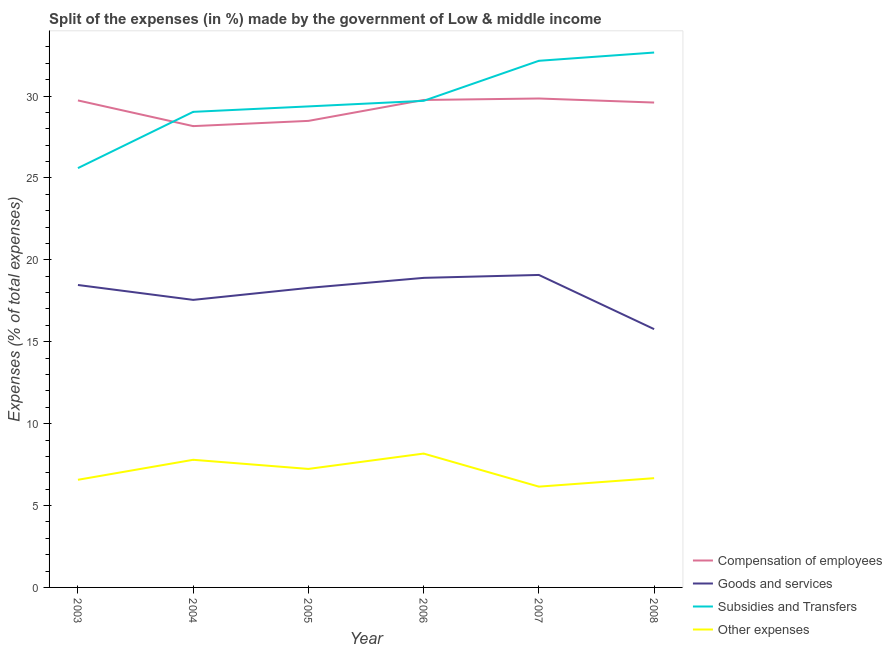How many different coloured lines are there?
Your response must be concise. 4. Does the line corresponding to percentage of amount spent on other expenses intersect with the line corresponding to percentage of amount spent on subsidies?
Your answer should be very brief. No. Is the number of lines equal to the number of legend labels?
Your answer should be very brief. Yes. What is the percentage of amount spent on subsidies in 2007?
Make the answer very short. 32.15. Across all years, what is the maximum percentage of amount spent on compensation of employees?
Your response must be concise. 29.85. Across all years, what is the minimum percentage of amount spent on other expenses?
Ensure brevity in your answer.  6.15. In which year was the percentage of amount spent on goods and services minimum?
Provide a short and direct response. 2008. What is the total percentage of amount spent on other expenses in the graph?
Make the answer very short. 42.6. What is the difference between the percentage of amount spent on subsidies in 2003 and that in 2008?
Keep it short and to the point. -7.06. What is the difference between the percentage of amount spent on subsidies in 2004 and the percentage of amount spent on compensation of employees in 2005?
Your answer should be compact. 0.55. What is the average percentage of amount spent on other expenses per year?
Give a very brief answer. 7.1. In the year 2008, what is the difference between the percentage of amount spent on subsidies and percentage of amount spent on other expenses?
Keep it short and to the point. 25.99. What is the ratio of the percentage of amount spent on goods and services in 2007 to that in 2008?
Give a very brief answer. 1.21. What is the difference between the highest and the second highest percentage of amount spent on compensation of employees?
Provide a short and direct response. 0.09. What is the difference between the highest and the lowest percentage of amount spent on goods and services?
Your answer should be very brief. 3.31. Is the sum of the percentage of amount spent on compensation of employees in 2006 and 2008 greater than the maximum percentage of amount spent on goods and services across all years?
Your answer should be compact. Yes. Is it the case that in every year, the sum of the percentage of amount spent on compensation of employees and percentage of amount spent on goods and services is greater than the percentage of amount spent on subsidies?
Provide a succinct answer. Yes. Is the percentage of amount spent on compensation of employees strictly greater than the percentage of amount spent on subsidies over the years?
Your answer should be very brief. No. Is the percentage of amount spent on other expenses strictly less than the percentage of amount spent on subsidies over the years?
Provide a short and direct response. Yes. How many lines are there?
Your response must be concise. 4. How many years are there in the graph?
Your response must be concise. 6. What is the difference between two consecutive major ticks on the Y-axis?
Make the answer very short. 5. Are the values on the major ticks of Y-axis written in scientific E-notation?
Provide a short and direct response. No. Does the graph contain any zero values?
Provide a succinct answer. No. Does the graph contain grids?
Provide a short and direct response. No. Where does the legend appear in the graph?
Ensure brevity in your answer.  Bottom right. How many legend labels are there?
Make the answer very short. 4. What is the title of the graph?
Ensure brevity in your answer.  Split of the expenses (in %) made by the government of Low & middle income. Does "Management rating" appear as one of the legend labels in the graph?
Ensure brevity in your answer.  No. What is the label or title of the Y-axis?
Make the answer very short. Expenses (% of total expenses). What is the Expenses (% of total expenses) in Compensation of employees in 2003?
Keep it short and to the point. 29.73. What is the Expenses (% of total expenses) in Goods and services in 2003?
Ensure brevity in your answer.  18.46. What is the Expenses (% of total expenses) in Subsidies and Transfers in 2003?
Make the answer very short. 25.6. What is the Expenses (% of total expenses) in Other expenses in 2003?
Keep it short and to the point. 6.57. What is the Expenses (% of total expenses) in Compensation of employees in 2004?
Give a very brief answer. 28.17. What is the Expenses (% of total expenses) in Goods and services in 2004?
Give a very brief answer. 17.56. What is the Expenses (% of total expenses) of Subsidies and Transfers in 2004?
Keep it short and to the point. 29.04. What is the Expenses (% of total expenses) of Other expenses in 2004?
Offer a terse response. 7.79. What is the Expenses (% of total expenses) in Compensation of employees in 2005?
Provide a short and direct response. 28.48. What is the Expenses (% of total expenses) in Goods and services in 2005?
Your answer should be very brief. 18.29. What is the Expenses (% of total expenses) in Subsidies and Transfers in 2005?
Provide a succinct answer. 29.37. What is the Expenses (% of total expenses) of Other expenses in 2005?
Keep it short and to the point. 7.24. What is the Expenses (% of total expenses) of Compensation of employees in 2006?
Your answer should be compact. 29.76. What is the Expenses (% of total expenses) of Goods and services in 2006?
Your answer should be compact. 18.9. What is the Expenses (% of total expenses) in Subsidies and Transfers in 2006?
Make the answer very short. 29.71. What is the Expenses (% of total expenses) of Other expenses in 2006?
Make the answer very short. 8.17. What is the Expenses (% of total expenses) of Compensation of employees in 2007?
Your response must be concise. 29.85. What is the Expenses (% of total expenses) of Goods and services in 2007?
Offer a very short reply. 19.08. What is the Expenses (% of total expenses) in Subsidies and Transfers in 2007?
Offer a terse response. 32.15. What is the Expenses (% of total expenses) in Other expenses in 2007?
Offer a terse response. 6.15. What is the Expenses (% of total expenses) of Compensation of employees in 2008?
Your response must be concise. 29.6. What is the Expenses (% of total expenses) in Goods and services in 2008?
Provide a succinct answer. 15.77. What is the Expenses (% of total expenses) of Subsidies and Transfers in 2008?
Your response must be concise. 32.66. What is the Expenses (% of total expenses) in Other expenses in 2008?
Provide a succinct answer. 6.67. Across all years, what is the maximum Expenses (% of total expenses) in Compensation of employees?
Keep it short and to the point. 29.85. Across all years, what is the maximum Expenses (% of total expenses) of Goods and services?
Your answer should be compact. 19.08. Across all years, what is the maximum Expenses (% of total expenses) in Subsidies and Transfers?
Your answer should be compact. 32.66. Across all years, what is the maximum Expenses (% of total expenses) of Other expenses?
Your answer should be compact. 8.17. Across all years, what is the minimum Expenses (% of total expenses) of Compensation of employees?
Offer a terse response. 28.17. Across all years, what is the minimum Expenses (% of total expenses) in Goods and services?
Your response must be concise. 15.77. Across all years, what is the minimum Expenses (% of total expenses) in Subsidies and Transfers?
Keep it short and to the point. 25.6. Across all years, what is the minimum Expenses (% of total expenses) of Other expenses?
Give a very brief answer. 6.15. What is the total Expenses (% of total expenses) in Compensation of employees in the graph?
Your answer should be very brief. 175.6. What is the total Expenses (% of total expenses) in Goods and services in the graph?
Keep it short and to the point. 108.06. What is the total Expenses (% of total expenses) of Subsidies and Transfers in the graph?
Make the answer very short. 178.53. What is the total Expenses (% of total expenses) in Other expenses in the graph?
Offer a very short reply. 42.6. What is the difference between the Expenses (% of total expenses) in Compensation of employees in 2003 and that in 2004?
Offer a terse response. 1.57. What is the difference between the Expenses (% of total expenses) of Goods and services in 2003 and that in 2004?
Offer a very short reply. 0.91. What is the difference between the Expenses (% of total expenses) in Subsidies and Transfers in 2003 and that in 2004?
Offer a terse response. -3.43. What is the difference between the Expenses (% of total expenses) in Other expenses in 2003 and that in 2004?
Your answer should be very brief. -1.22. What is the difference between the Expenses (% of total expenses) in Compensation of employees in 2003 and that in 2005?
Your response must be concise. 1.25. What is the difference between the Expenses (% of total expenses) of Goods and services in 2003 and that in 2005?
Ensure brevity in your answer.  0.18. What is the difference between the Expenses (% of total expenses) in Subsidies and Transfers in 2003 and that in 2005?
Ensure brevity in your answer.  -3.77. What is the difference between the Expenses (% of total expenses) of Other expenses in 2003 and that in 2005?
Give a very brief answer. -0.66. What is the difference between the Expenses (% of total expenses) of Compensation of employees in 2003 and that in 2006?
Offer a terse response. -0.03. What is the difference between the Expenses (% of total expenses) in Goods and services in 2003 and that in 2006?
Your response must be concise. -0.44. What is the difference between the Expenses (% of total expenses) of Subsidies and Transfers in 2003 and that in 2006?
Make the answer very short. -4.11. What is the difference between the Expenses (% of total expenses) of Other expenses in 2003 and that in 2006?
Give a very brief answer. -1.6. What is the difference between the Expenses (% of total expenses) in Compensation of employees in 2003 and that in 2007?
Ensure brevity in your answer.  -0.12. What is the difference between the Expenses (% of total expenses) in Goods and services in 2003 and that in 2007?
Ensure brevity in your answer.  -0.61. What is the difference between the Expenses (% of total expenses) of Subsidies and Transfers in 2003 and that in 2007?
Provide a succinct answer. -6.55. What is the difference between the Expenses (% of total expenses) in Other expenses in 2003 and that in 2007?
Offer a very short reply. 0.42. What is the difference between the Expenses (% of total expenses) in Compensation of employees in 2003 and that in 2008?
Make the answer very short. 0.13. What is the difference between the Expenses (% of total expenses) in Goods and services in 2003 and that in 2008?
Offer a terse response. 2.69. What is the difference between the Expenses (% of total expenses) of Subsidies and Transfers in 2003 and that in 2008?
Provide a succinct answer. -7.06. What is the difference between the Expenses (% of total expenses) in Other expenses in 2003 and that in 2008?
Make the answer very short. -0.1. What is the difference between the Expenses (% of total expenses) in Compensation of employees in 2004 and that in 2005?
Give a very brief answer. -0.32. What is the difference between the Expenses (% of total expenses) in Goods and services in 2004 and that in 2005?
Offer a very short reply. -0.73. What is the difference between the Expenses (% of total expenses) of Subsidies and Transfers in 2004 and that in 2005?
Keep it short and to the point. -0.33. What is the difference between the Expenses (% of total expenses) in Other expenses in 2004 and that in 2005?
Keep it short and to the point. 0.56. What is the difference between the Expenses (% of total expenses) of Compensation of employees in 2004 and that in 2006?
Offer a terse response. -1.6. What is the difference between the Expenses (% of total expenses) in Goods and services in 2004 and that in 2006?
Your response must be concise. -1.34. What is the difference between the Expenses (% of total expenses) in Subsidies and Transfers in 2004 and that in 2006?
Keep it short and to the point. -0.67. What is the difference between the Expenses (% of total expenses) in Other expenses in 2004 and that in 2006?
Give a very brief answer. -0.38. What is the difference between the Expenses (% of total expenses) of Compensation of employees in 2004 and that in 2007?
Ensure brevity in your answer.  -1.69. What is the difference between the Expenses (% of total expenses) in Goods and services in 2004 and that in 2007?
Provide a short and direct response. -1.52. What is the difference between the Expenses (% of total expenses) in Subsidies and Transfers in 2004 and that in 2007?
Your response must be concise. -3.12. What is the difference between the Expenses (% of total expenses) in Other expenses in 2004 and that in 2007?
Keep it short and to the point. 1.64. What is the difference between the Expenses (% of total expenses) in Compensation of employees in 2004 and that in 2008?
Your response must be concise. -1.44. What is the difference between the Expenses (% of total expenses) in Goods and services in 2004 and that in 2008?
Provide a short and direct response. 1.79. What is the difference between the Expenses (% of total expenses) of Subsidies and Transfers in 2004 and that in 2008?
Offer a very short reply. -3.62. What is the difference between the Expenses (% of total expenses) in Other expenses in 2004 and that in 2008?
Offer a terse response. 1.12. What is the difference between the Expenses (% of total expenses) in Compensation of employees in 2005 and that in 2006?
Make the answer very short. -1.28. What is the difference between the Expenses (% of total expenses) in Goods and services in 2005 and that in 2006?
Keep it short and to the point. -0.61. What is the difference between the Expenses (% of total expenses) of Subsidies and Transfers in 2005 and that in 2006?
Your answer should be compact. -0.34. What is the difference between the Expenses (% of total expenses) of Other expenses in 2005 and that in 2006?
Your answer should be very brief. -0.94. What is the difference between the Expenses (% of total expenses) of Compensation of employees in 2005 and that in 2007?
Give a very brief answer. -1.37. What is the difference between the Expenses (% of total expenses) of Goods and services in 2005 and that in 2007?
Make the answer very short. -0.79. What is the difference between the Expenses (% of total expenses) of Subsidies and Transfers in 2005 and that in 2007?
Your answer should be compact. -2.78. What is the difference between the Expenses (% of total expenses) of Other expenses in 2005 and that in 2007?
Give a very brief answer. 1.08. What is the difference between the Expenses (% of total expenses) in Compensation of employees in 2005 and that in 2008?
Your answer should be very brief. -1.12. What is the difference between the Expenses (% of total expenses) of Goods and services in 2005 and that in 2008?
Give a very brief answer. 2.52. What is the difference between the Expenses (% of total expenses) of Subsidies and Transfers in 2005 and that in 2008?
Offer a terse response. -3.29. What is the difference between the Expenses (% of total expenses) in Other expenses in 2005 and that in 2008?
Your answer should be compact. 0.56. What is the difference between the Expenses (% of total expenses) of Compensation of employees in 2006 and that in 2007?
Provide a succinct answer. -0.09. What is the difference between the Expenses (% of total expenses) of Goods and services in 2006 and that in 2007?
Keep it short and to the point. -0.18. What is the difference between the Expenses (% of total expenses) of Subsidies and Transfers in 2006 and that in 2007?
Ensure brevity in your answer.  -2.44. What is the difference between the Expenses (% of total expenses) in Other expenses in 2006 and that in 2007?
Your response must be concise. 2.02. What is the difference between the Expenses (% of total expenses) in Compensation of employees in 2006 and that in 2008?
Keep it short and to the point. 0.16. What is the difference between the Expenses (% of total expenses) in Goods and services in 2006 and that in 2008?
Your answer should be compact. 3.13. What is the difference between the Expenses (% of total expenses) of Subsidies and Transfers in 2006 and that in 2008?
Make the answer very short. -2.95. What is the difference between the Expenses (% of total expenses) of Other expenses in 2006 and that in 2008?
Keep it short and to the point. 1.5. What is the difference between the Expenses (% of total expenses) of Compensation of employees in 2007 and that in 2008?
Provide a short and direct response. 0.25. What is the difference between the Expenses (% of total expenses) of Goods and services in 2007 and that in 2008?
Ensure brevity in your answer.  3.31. What is the difference between the Expenses (% of total expenses) in Subsidies and Transfers in 2007 and that in 2008?
Your response must be concise. -0.5. What is the difference between the Expenses (% of total expenses) in Other expenses in 2007 and that in 2008?
Make the answer very short. -0.52. What is the difference between the Expenses (% of total expenses) of Compensation of employees in 2003 and the Expenses (% of total expenses) of Goods and services in 2004?
Give a very brief answer. 12.18. What is the difference between the Expenses (% of total expenses) of Compensation of employees in 2003 and the Expenses (% of total expenses) of Subsidies and Transfers in 2004?
Give a very brief answer. 0.7. What is the difference between the Expenses (% of total expenses) in Compensation of employees in 2003 and the Expenses (% of total expenses) in Other expenses in 2004?
Offer a very short reply. 21.94. What is the difference between the Expenses (% of total expenses) in Goods and services in 2003 and the Expenses (% of total expenses) in Subsidies and Transfers in 2004?
Provide a succinct answer. -10.57. What is the difference between the Expenses (% of total expenses) in Goods and services in 2003 and the Expenses (% of total expenses) in Other expenses in 2004?
Offer a very short reply. 10.67. What is the difference between the Expenses (% of total expenses) in Subsidies and Transfers in 2003 and the Expenses (% of total expenses) in Other expenses in 2004?
Make the answer very short. 17.81. What is the difference between the Expenses (% of total expenses) of Compensation of employees in 2003 and the Expenses (% of total expenses) of Goods and services in 2005?
Offer a very short reply. 11.45. What is the difference between the Expenses (% of total expenses) in Compensation of employees in 2003 and the Expenses (% of total expenses) in Subsidies and Transfers in 2005?
Your answer should be compact. 0.36. What is the difference between the Expenses (% of total expenses) in Compensation of employees in 2003 and the Expenses (% of total expenses) in Other expenses in 2005?
Ensure brevity in your answer.  22.5. What is the difference between the Expenses (% of total expenses) of Goods and services in 2003 and the Expenses (% of total expenses) of Subsidies and Transfers in 2005?
Offer a very short reply. -10.9. What is the difference between the Expenses (% of total expenses) in Goods and services in 2003 and the Expenses (% of total expenses) in Other expenses in 2005?
Ensure brevity in your answer.  11.23. What is the difference between the Expenses (% of total expenses) in Subsidies and Transfers in 2003 and the Expenses (% of total expenses) in Other expenses in 2005?
Your answer should be compact. 18.37. What is the difference between the Expenses (% of total expenses) of Compensation of employees in 2003 and the Expenses (% of total expenses) of Goods and services in 2006?
Your response must be concise. 10.83. What is the difference between the Expenses (% of total expenses) in Compensation of employees in 2003 and the Expenses (% of total expenses) in Subsidies and Transfers in 2006?
Keep it short and to the point. 0.02. What is the difference between the Expenses (% of total expenses) of Compensation of employees in 2003 and the Expenses (% of total expenses) of Other expenses in 2006?
Offer a very short reply. 21.56. What is the difference between the Expenses (% of total expenses) in Goods and services in 2003 and the Expenses (% of total expenses) in Subsidies and Transfers in 2006?
Keep it short and to the point. -11.24. What is the difference between the Expenses (% of total expenses) of Goods and services in 2003 and the Expenses (% of total expenses) of Other expenses in 2006?
Your answer should be very brief. 10.29. What is the difference between the Expenses (% of total expenses) in Subsidies and Transfers in 2003 and the Expenses (% of total expenses) in Other expenses in 2006?
Make the answer very short. 17.43. What is the difference between the Expenses (% of total expenses) of Compensation of employees in 2003 and the Expenses (% of total expenses) of Goods and services in 2007?
Your response must be concise. 10.66. What is the difference between the Expenses (% of total expenses) in Compensation of employees in 2003 and the Expenses (% of total expenses) in Subsidies and Transfers in 2007?
Provide a succinct answer. -2.42. What is the difference between the Expenses (% of total expenses) of Compensation of employees in 2003 and the Expenses (% of total expenses) of Other expenses in 2007?
Ensure brevity in your answer.  23.58. What is the difference between the Expenses (% of total expenses) of Goods and services in 2003 and the Expenses (% of total expenses) of Subsidies and Transfers in 2007?
Your response must be concise. -13.69. What is the difference between the Expenses (% of total expenses) of Goods and services in 2003 and the Expenses (% of total expenses) of Other expenses in 2007?
Keep it short and to the point. 12.31. What is the difference between the Expenses (% of total expenses) in Subsidies and Transfers in 2003 and the Expenses (% of total expenses) in Other expenses in 2007?
Your answer should be very brief. 19.45. What is the difference between the Expenses (% of total expenses) in Compensation of employees in 2003 and the Expenses (% of total expenses) in Goods and services in 2008?
Keep it short and to the point. 13.96. What is the difference between the Expenses (% of total expenses) in Compensation of employees in 2003 and the Expenses (% of total expenses) in Subsidies and Transfers in 2008?
Make the answer very short. -2.92. What is the difference between the Expenses (% of total expenses) in Compensation of employees in 2003 and the Expenses (% of total expenses) in Other expenses in 2008?
Give a very brief answer. 23.06. What is the difference between the Expenses (% of total expenses) of Goods and services in 2003 and the Expenses (% of total expenses) of Subsidies and Transfers in 2008?
Provide a short and direct response. -14.19. What is the difference between the Expenses (% of total expenses) of Goods and services in 2003 and the Expenses (% of total expenses) of Other expenses in 2008?
Offer a very short reply. 11.79. What is the difference between the Expenses (% of total expenses) in Subsidies and Transfers in 2003 and the Expenses (% of total expenses) in Other expenses in 2008?
Give a very brief answer. 18.93. What is the difference between the Expenses (% of total expenses) in Compensation of employees in 2004 and the Expenses (% of total expenses) in Goods and services in 2005?
Make the answer very short. 9.88. What is the difference between the Expenses (% of total expenses) of Compensation of employees in 2004 and the Expenses (% of total expenses) of Subsidies and Transfers in 2005?
Offer a terse response. -1.2. What is the difference between the Expenses (% of total expenses) in Compensation of employees in 2004 and the Expenses (% of total expenses) in Other expenses in 2005?
Offer a very short reply. 20.93. What is the difference between the Expenses (% of total expenses) of Goods and services in 2004 and the Expenses (% of total expenses) of Subsidies and Transfers in 2005?
Ensure brevity in your answer.  -11.81. What is the difference between the Expenses (% of total expenses) of Goods and services in 2004 and the Expenses (% of total expenses) of Other expenses in 2005?
Offer a terse response. 10.32. What is the difference between the Expenses (% of total expenses) of Subsidies and Transfers in 2004 and the Expenses (% of total expenses) of Other expenses in 2005?
Your response must be concise. 21.8. What is the difference between the Expenses (% of total expenses) in Compensation of employees in 2004 and the Expenses (% of total expenses) in Goods and services in 2006?
Your answer should be compact. 9.26. What is the difference between the Expenses (% of total expenses) of Compensation of employees in 2004 and the Expenses (% of total expenses) of Subsidies and Transfers in 2006?
Provide a succinct answer. -1.54. What is the difference between the Expenses (% of total expenses) in Compensation of employees in 2004 and the Expenses (% of total expenses) in Other expenses in 2006?
Provide a short and direct response. 19.99. What is the difference between the Expenses (% of total expenses) in Goods and services in 2004 and the Expenses (% of total expenses) in Subsidies and Transfers in 2006?
Provide a succinct answer. -12.15. What is the difference between the Expenses (% of total expenses) in Goods and services in 2004 and the Expenses (% of total expenses) in Other expenses in 2006?
Offer a terse response. 9.38. What is the difference between the Expenses (% of total expenses) of Subsidies and Transfers in 2004 and the Expenses (% of total expenses) of Other expenses in 2006?
Provide a short and direct response. 20.86. What is the difference between the Expenses (% of total expenses) of Compensation of employees in 2004 and the Expenses (% of total expenses) of Goods and services in 2007?
Your response must be concise. 9.09. What is the difference between the Expenses (% of total expenses) of Compensation of employees in 2004 and the Expenses (% of total expenses) of Subsidies and Transfers in 2007?
Offer a very short reply. -3.99. What is the difference between the Expenses (% of total expenses) in Compensation of employees in 2004 and the Expenses (% of total expenses) in Other expenses in 2007?
Provide a succinct answer. 22.01. What is the difference between the Expenses (% of total expenses) of Goods and services in 2004 and the Expenses (% of total expenses) of Subsidies and Transfers in 2007?
Your answer should be very brief. -14.6. What is the difference between the Expenses (% of total expenses) of Goods and services in 2004 and the Expenses (% of total expenses) of Other expenses in 2007?
Your answer should be compact. 11.4. What is the difference between the Expenses (% of total expenses) of Subsidies and Transfers in 2004 and the Expenses (% of total expenses) of Other expenses in 2007?
Offer a terse response. 22.88. What is the difference between the Expenses (% of total expenses) in Compensation of employees in 2004 and the Expenses (% of total expenses) in Goods and services in 2008?
Your response must be concise. 12.4. What is the difference between the Expenses (% of total expenses) of Compensation of employees in 2004 and the Expenses (% of total expenses) of Subsidies and Transfers in 2008?
Provide a succinct answer. -4.49. What is the difference between the Expenses (% of total expenses) in Compensation of employees in 2004 and the Expenses (% of total expenses) in Other expenses in 2008?
Make the answer very short. 21.49. What is the difference between the Expenses (% of total expenses) of Goods and services in 2004 and the Expenses (% of total expenses) of Subsidies and Transfers in 2008?
Offer a very short reply. -15.1. What is the difference between the Expenses (% of total expenses) of Goods and services in 2004 and the Expenses (% of total expenses) of Other expenses in 2008?
Ensure brevity in your answer.  10.89. What is the difference between the Expenses (% of total expenses) in Subsidies and Transfers in 2004 and the Expenses (% of total expenses) in Other expenses in 2008?
Keep it short and to the point. 22.37. What is the difference between the Expenses (% of total expenses) in Compensation of employees in 2005 and the Expenses (% of total expenses) in Goods and services in 2006?
Offer a very short reply. 9.58. What is the difference between the Expenses (% of total expenses) of Compensation of employees in 2005 and the Expenses (% of total expenses) of Subsidies and Transfers in 2006?
Your answer should be compact. -1.22. What is the difference between the Expenses (% of total expenses) in Compensation of employees in 2005 and the Expenses (% of total expenses) in Other expenses in 2006?
Keep it short and to the point. 20.31. What is the difference between the Expenses (% of total expenses) of Goods and services in 2005 and the Expenses (% of total expenses) of Subsidies and Transfers in 2006?
Offer a very short reply. -11.42. What is the difference between the Expenses (% of total expenses) of Goods and services in 2005 and the Expenses (% of total expenses) of Other expenses in 2006?
Keep it short and to the point. 10.11. What is the difference between the Expenses (% of total expenses) of Subsidies and Transfers in 2005 and the Expenses (% of total expenses) of Other expenses in 2006?
Your response must be concise. 21.2. What is the difference between the Expenses (% of total expenses) in Compensation of employees in 2005 and the Expenses (% of total expenses) in Goods and services in 2007?
Give a very brief answer. 9.41. What is the difference between the Expenses (% of total expenses) in Compensation of employees in 2005 and the Expenses (% of total expenses) in Subsidies and Transfers in 2007?
Your answer should be very brief. -3.67. What is the difference between the Expenses (% of total expenses) in Compensation of employees in 2005 and the Expenses (% of total expenses) in Other expenses in 2007?
Keep it short and to the point. 22.33. What is the difference between the Expenses (% of total expenses) in Goods and services in 2005 and the Expenses (% of total expenses) in Subsidies and Transfers in 2007?
Provide a succinct answer. -13.87. What is the difference between the Expenses (% of total expenses) in Goods and services in 2005 and the Expenses (% of total expenses) in Other expenses in 2007?
Give a very brief answer. 12.13. What is the difference between the Expenses (% of total expenses) in Subsidies and Transfers in 2005 and the Expenses (% of total expenses) in Other expenses in 2007?
Make the answer very short. 23.22. What is the difference between the Expenses (% of total expenses) of Compensation of employees in 2005 and the Expenses (% of total expenses) of Goods and services in 2008?
Your answer should be very brief. 12.71. What is the difference between the Expenses (% of total expenses) in Compensation of employees in 2005 and the Expenses (% of total expenses) in Subsidies and Transfers in 2008?
Provide a short and direct response. -4.17. What is the difference between the Expenses (% of total expenses) in Compensation of employees in 2005 and the Expenses (% of total expenses) in Other expenses in 2008?
Provide a short and direct response. 21.81. What is the difference between the Expenses (% of total expenses) of Goods and services in 2005 and the Expenses (% of total expenses) of Subsidies and Transfers in 2008?
Give a very brief answer. -14.37. What is the difference between the Expenses (% of total expenses) in Goods and services in 2005 and the Expenses (% of total expenses) in Other expenses in 2008?
Keep it short and to the point. 11.62. What is the difference between the Expenses (% of total expenses) in Subsidies and Transfers in 2005 and the Expenses (% of total expenses) in Other expenses in 2008?
Ensure brevity in your answer.  22.7. What is the difference between the Expenses (% of total expenses) in Compensation of employees in 2006 and the Expenses (% of total expenses) in Goods and services in 2007?
Keep it short and to the point. 10.68. What is the difference between the Expenses (% of total expenses) of Compensation of employees in 2006 and the Expenses (% of total expenses) of Subsidies and Transfers in 2007?
Make the answer very short. -2.39. What is the difference between the Expenses (% of total expenses) in Compensation of employees in 2006 and the Expenses (% of total expenses) in Other expenses in 2007?
Provide a succinct answer. 23.61. What is the difference between the Expenses (% of total expenses) in Goods and services in 2006 and the Expenses (% of total expenses) in Subsidies and Transfers in 2007?
Your response must be concise. -13.25. What is the difference between the Expenses (% of total expenses) of Goods and services in 2006 and the Expenses (% of total expenses) of Other expenses in 2007?
Offer a terse response. 12.75. What is the difference between the Expenses (% of total expenses) of Subsidies and Transfers in 2006 and the Expenses (% of total expenses) of Other expenses in 2007?
Your answer should be compact. 23.56. What is the difference between the Expenses (% of total expenses) in Compensation of employees in 2006 and the Expenses (% of total expenses) in Goods and services in 2008?
Your answer should be compact. 13.99. What is the difference between the Expenses (% of total expenses) of Compensation of employees in 2006 and the Expenses (% of total expenses) of Subsidies and Transfers in 2008?
Offer a very short reply. -2.9. What is the difference between the Expenses (% of total expenses) of Compensation of employees in 2006 and the Expenses (% of total expenses) of Other expenses in 2008?
Offer a very short reply. 23.09. What is the difference between the Expenses (% of total expenses) of Goods and services in 2006 and the Expenses (% of total expenses) of Subsidies and Transfers in 2008?
Offer a very short reply. -13.76. What is the difference between the Expenses (% of total expenses) in Goods and services in 2006 and the Expenses (% of total expenses) in Other expenses in 2008?
Keep it short and to the point. 12.23. What is the difference between the Expenses (% of total expenses) of Subsidies and Transfers in 2006 and the Expenses (% of total expenses) of Other expenses in 2008?
Give a very brief answer. 23.04. What is the difference between the Expenses (% of total expenses) in Compensation of employees in 2007 and the Expenses (% of total expenses) in Goods and services in 2008?
Offer a terse response. 14.08. What is the difference between the Expenses (% of total expenses) of Compensation of employees in 2007 and the Expenses (% of total expenses) of Subsidies and Transfers in 2008?
Your answer should be compact. -2.81. What is the difference between the Expenses (% of total expenses) of Compensation of employees in 2007 and the Expenses (% of total expenses) of Other expenses in 2008?
Give a very brief answer. 23.18. What is the difference between the Expenses (% of total expenses) of Goods and services in 2007 and the Expenses (% of total expenses) of Subsidies and Transfers in 2008?
Give a very brief answer. -13.58. What is the difference between the Expenses (% of total expenses) in Goods and services in 2007 and the Expenses (% of total expenses) in Other expenses in 2008?
Ensure brevity in your answer.  12.41. What is the difference between the Expenses (% of total expenses) in Subsidies and Transfers in 2007 and the Expenses (% of total expenses) in Other expenses in 2008?
Make the answer very short. 25.48. What is the average Expenses (% of total expenses) in Compensation of employees per year?
Make the answer very short. 29.27. What is the average Expenses (% of total expenses) of Goods and services per year?
Offer a very short reply. 18.01. What is the average Expenses (% of total expenses) in Subsidies and Transfers per year?
Ensure brevity in your answer.  29.75. What is the average Expenses (% of total expenses) of Other expenses per year?
Provide a succinct answer. 7.1. In the year 2003, what is the difference between the Expenses (% of total expenses) in Compensation of employees and Expenses (% of total expenses) in Goods and services?
Make the answer very short. 11.27. In the year 2003, what is the difference between the Expenses (% of total expenses) of Compensation of employees and Expenses (% of total expenses) of Subsidies and Transfers?
Your answer should be compact. 4.13. In the year 2003, what is the difference between the Expenses (% of total expenses) in Compensation of employees and Expenses (% of total expenses) in Other expenses?
Your response must be concise. 23.16. In the year 2003, what is the difference between the Expenses (% of total expenses) in Goods and services and Expenses (% of total expenses) in Subsidies and Transfers?
Offer a terse response. -7.14. In the year 2003, what is the difference between the Expenses (% of total expenses) in Goods and services and Expenses (% of total expenses) in Other expenses?
Ensure brevity in your answer.  11.89. In the year 2003, what is the difference between the Expenses (% of total expenses) of Subsidies and Transfers and Expenses (% of total expenses) of Other expenses?
Offer a terse response. 19.03. In the year 2004, what is the difference between the Expenses (% of total expenses) in Compensation of employees and Expenses (% of total expenses) in Goods and services?
Make the answer very short. 10.61. In the year 2004, what is the difference between the Expenses (% of total expenses) of Compensation of employees and Expenses (% of total expenses) of Subsidies and Transfers?
Your answer should be compact. -0.87. In the year 2004, what is the difference between the Expenses (% of total expenses) of Compensation of employees and Expenses (% of total expenses) of Other expenses?
Your response must be concise. 20.37. In the year 2004, what is the difference between the Expenses (% of total expenses) of Goods and services and Expenses (% of total expenses) of Subsidies and Transfers?
Make the answer very short. -11.48. In the year 2004, what is the difference between the Expenses (% of total expenses) in Goods and services and Expenses (% of total expenses) in Other expenses?
Provide a succinct answer. 9.76. In the year 2004, what is the difference between the Expenses (% of total expenses) of Subsidies and Transfers and Expenses (% of total expenses) of Other expenses?
Ensure brevity in your answer.  21.24. In the year 2005, what is the difference between the Expenses (% of total expenses) of Compensation of employees and Expenses (% of total expenses) of Goods and services?
Keep it short and to the point. 10.2. In the year 2005, what is the difference between the Expenses (% of total expenses) in Compensation of employees and Expenses (% of total expenses) in Subsidies and Transfers?
Give a very brief answer. -0.88. In the year 2005, what is the difference between the Expenses (% of total expenses) in Compensation of employees and Expenses (% of total expenses) in Other expenses?
Ensure brevity in your answer.  21.25. In the year 2005, what is the difference between the Expenses (% of total expenses) of Goods and services and Expenses (% of total expenses) of Subsidies and Transfers?
Offer a terse response. -11.08. In the year 2005, what is the difference between the Expenses (% of total expenses) in Goods and services and Expenses (% of total expenses) in Other expenses?
Ensure brevity in your answer.  11.05. In the year 2005, what is the difference between the Expenses (% of total expenses) in Subsidies and Transfers and Expenses (% of total expenses) in Other expenses?
Provide a succinct answer. 22.13. In the year 2006, what is the difference between the Expenses (% of total expenses) in Compensation of employees and Expenses (% of total expenses) in Goods and services?
Your answer should be very brief. 10.86. In the year 2006, what is the difference between the Expenses (% of total expenses) of Compensation of employees and Expenses (% of total expenses) of Subsidies and Transfers?
Offer a very short reply. 0.05. In the year 2006, what is the difference between the Expenses (% of total expenses) in Compensation of employees and Expenses (% of total expenses) in Other expenses?
Your answer should be very brief. 21.59. In the year 2006, what is the difference between the Expenses (% of total expenses) in Goods and services and Expenses (% of total expenses) in Subsidies and Transfers?
Keep it short and to the point. -10.81. In the year 2006, what is the difference between the Expenses (% of total expenses) in Goods and services and Expenses (% of total expenses) in Other expenses?
Ensure brevity in your answer.  10.73. In the year 2006, what is the difference between the Expenses (% of total expenses) of Subsidies and Transfers and Expenses (% of total expenses) of Other expenses?
Make the answer very short. 21.54. In the year 2007, what is the difference between the Expenses (% of total expenses) in Compensation of employees and Expenses (% of total expenses) in Goods and services?
Your response must be concise. 10.77. In the year 2007, what is the difference between the Expenses (% of total expenses) in Compensation of employees and Expenses (% of total expenses) in Subsidies and Transfers?
Make the answer very short. -2.3. In the year 2007, what is the difference between the Expenses (% of total expenses) of Compensation of employees and Expenses (% of total expenses) of Other expenses?
Your answer should be compact. 23.7. In the year 2007, what is the difference between the Expenses (% of total expenses) in Goods and services and Expenses (% of total expenses) in Subsidies and Transfers?
Provide a short and direct response. -13.08. In the year 2007, what is the difference between the Expenses (% of total expenses) in Goods and services and Expenses (% of total expenses) in Other expenses?
Give a very brief answer. 12.92. In the year 2007, what is the difference between the Expenses (% of total expenses) in Subsidies and Transfers and Expenses (% of total expenses) in Other expenses?
Provide a succinct answer. 26. In the year 2008, what is the difference between the Expenses (% of total expenses) in Compensation of employees and Expenses (% of total expenses) in Goods and services?
Provide a succinct answer. 13.83. In the year 2008, what is the difference between the Expenses (% of total expenses) of Compensation of employees and Expenses (% of total expenses) of Subsidies and Transfers?
Offer a very short reply. -3.05. In the year 2008, what is the difference between the Expenses (% of total expenses) of Compensation of employees and Expenses (% of total expenses) of Other expenses?
Provide a short and direct response. 22.93. In the year 2008, what is the difference between the Expenses (% of total expenses) of Goods and services and Expenses (% of total expenses) of Subsidies and Transfers?
Keep it short and to the point. -16.89. In the year 2008, what is the difference between the Expenses (% of total expenses) in Goods and services and Expenses (% of total expenses) in Other expenses?
Offer a terse response. 9.1. In the year 2008, what is the difference between the Expenses (% of total expenses) in Subsidies and Transfers and Expenses (% of total expenses) in Other expenses?
Ensure brevity in your answer.  25.99. What is the ratio of the Expenses (% of total expenses) in Compensation of employees in 2003 to that in 2004?
Offer a terse response. 1.06. What is the ratio of the Expenses (% of total expenses) in Goods and services in 2003 to that in 2004?
Offer a very short reply. 1.05. What is the ratio of the Expenses (% of total expenses) in Subsidies and Transfers in 2003 to that in 2004?
Give a very brief answer. 0.88. What is the ratio of the Expenses (% of total expenses) of Other expenses in 2003 to that in 2004?
Keep it short and to the point. 0.84. What is the ratio of the Expenses (% of total expenses) of Compensation of employees in 2003 to that in 2005?
Ensure brevity in your answer.  1.04. What is the ratio of the Expenses (% of total expenses) of Goods and services in 2003 to that in 2005?
Keep it short and to the point. 1.01. What is the ratio of the Expenses (% of total expenses) of Subsidies and Transfers in 2003 to that in 2005?
Your response must be concise. 0.87. What is the ratio of the Expenses (% of total expenses) of Other expenses in 2003 to that in 2005?
Offer a terse response. 0.91. What is the ratio of the Expenses (% of total expenses) in Compensation of employees in 2003 to that in 2006?
Your response must be concise. 1. What is the ratio of the Expenses (% of total expenses) of Subsidies and Transfers in 2003 to that in 2006?
Your answer should be compact. 0.86. What is the ratio of the Expenses (% of total expenses) of Other expenses in 2003 to that in 2006?
Your answer should be compact. 0.8. What is the ratio of the Expenses (% of total expenses) in Compensation of employees in 2003 to that in 2007?
Provide a short and direct response. 1. What is the ratio of the Expenses (% of total expenses) of Goods and services in 2003 to that in 2007?
Provide a succinct answer. 0.97. What is the ratio of the Expenses (% of total expenses) in Subsidies and Transfers in 2003 to that in 2007?
Offer a terse response. 0.8. What is the ratio of the Expenses (% of total expenses) of Other expenses in 2003 to that in 2007?
Your response must be concise. 1.07. What is the ratio of the Expenses (% of total expenses) in Compensation of employees in 2003 to that in 2008?
Provide a succinct answer. 1. What is the ratio of the Expenses (% of total expenses) in Goods and services in 2003 to that in 2008?
Offer a very short reply. 1.17. What is the ratio of the Expenses (% of total expenses) of Subsidies and Transfers in 2003 to that in 2008?
Provide a succinct answer. 0.78. What is the ratio of the Expenses (% of total expenses) of Goods and services in 2004 to that in 2005?
Your answer should be compact. 0.96. What is the ratio of the Expenses (% of total expenses) in Subsidies and Transfers in 2004 to that in 2005?
Make the answer very short. 0.99. What is the ratio of the Expenses (% of total expenses) in Other expenses in 2004 to that in 2005?
Your response must be concise. 1.08. What is the ratio of the Expenses (% of total expenses) of Compensation of employees in 2004 to that in 2006?
Your answer should be very brief. 0.95. What is the ratio of the Expenses (% of total expenses) in Goods and services in 2004 to that in 2006?
Your answer should be very brief. 0.93. What is the ratio of the Expenses (% of total expenses) in Subsidies and Transfers in 2004 to that in 2006?
Offer a very short reply. 0.98. What is the ratio of the Expenses (% of total expenses) of Other expenses in 2004 to that in 2006?
Your answer should be very brief. 0.95. What is the ratio of the Expenses (% of total expenses) of Compensation of employees in 2004 to that in 2007?
Provide a short and direct response. 0.94. What is the ratio of the Expenses (% of total expenses) of Goods and services in 2004 to that in 2007?
Your answer should be very brief. 0.92. What is the ratio of the Expenses (% of total expenses) of Subsidies and Transfers in 2004 to that in 2007?
Ensure brevity in your answer.  0.9. What is the ratio of the Expenses (% of total expenses) of Other expenses in 2004 to that in 2007?
Your answer should be very brief. 1.27. What is the ratio of the Expenses (% of total expenses) of Compensation of employees in 2004 to that in 2008?
Provide a short and direct response. 0.95. What is the ratio of the Expenses (% of total expenses) of Goods and services in 2004 to that in 2008?
Keep it short and to the point. 1.11. What is the ratio of the Expenses (% of total expenses) in Subsidies and Transfers in 2004 to that in 2008?
Provide a succinct answer. 0.89. What is the ratio of the Expenses (% of total expenses) in Other expenses in 2004 to that in 2008?
Provide a succinct answer. 1.17. What is the ratio of the Expenses (% of total expenses) of Compensation of employees in 2005 to that in 2006?
Your response must be concise. 0.96. What is the ratio of the Expenses (% of total expenses) of Goods and services in 2005 to that in 2006?
Keep it short and to the point. 0.97. What is the ratio of the Expenses (% of total expenses) of Subsidies and Transfers in 2005 to that in 2006?
Give a very brief answer. 0.99. What is the ratio of the Expenses (% of total expenses) of Other expenses in 2005 to that in 2006?
Give a very brief answer. 0.89. What is the ratio of the Expenses (% of total expenses) in Compensation of employees in 2005 to that in 2007?
Your answer should be compact. 0.95. What is the ratio of the Expenses (% of total expenses) of Goods and services in 2005 to that in 2007?
Provide a short and direct response. 0.96. What is the ratio of the Expenses (% of total expenses) of Subsidies and Transfers in 2005 to that in 2007?
Provide a short and direct response. 0.91. What is the ratio of the Expenses (% of total expenses) in Other expenses in 2005 to that in 2007?
Keep it short and to the point. 1.18. What is the ratio of the Expenses (% of total expenses) of Compensation of employees in 2005 to that in 2008?
Your answer should be very brief. 0.96. What is the ratio of the Expenses (% of total expenses) of Goods and services in 2005 to that in 2008?
Offer a very short reply. 1.16. What is the ratio of the Expenses (% of total expenses) in Subsidies and Transfers in 2005 to that in 2008?
Your response must be concise. 0.9. What is the ratio of the Expenses (% of total expenses) of Other expenses in 2005 to that in 2008?
Your response must be concise. 1.08. What is the ratio of the Expenses (% of total expenses) in Compensation of employees in 2006 to that in 2007?
Keep it short and to the point. 1. What is the ratio of the Expenses (% of total expenses) of Goods and services in 2006 to that in 2007?
Your answer should be compact. 0.99. What is the ratio of the Expenses (% of total expenses) of Subsidies and Transfers in 2006 to that in 2007?
Ensure brevity in your answer.  0.92. What is the ratio of the Expenses (% of total expenses) of Other expenses in 2006 to that in 2007?
Keep it short and to the point. 1.33. What is the ratio of the Expenses (% of total expenses) in Compensation of employees in 2006 to that in 2008?
Provide a succinct answer. 1.01. What is the ratio of the Expenses (% of total expenses) of Goods and services in 2006 to that in 2008?
Make the answer very short. 1.2. What is the ratio of the Expenses (% of total expenses) of Subsidies and Transfers in 2006 to that in 2008?
Keep it short and to the point. 0.91. What is the ratio of the Expenses (% of total expenses) of Other expenses in 2006 to that in 2008?
Offer a terse response. 1.23. What is the ratio of the Expenses (% of total expenses) in Compensation of employees in 2007 to that in 2008?
Offer a terse response. 1.01. What is the ratio of the Expenses (% of total expenses) in Goods and services in 2007 to that in 2008?
Provide a short and direct response. 1.21. What is the ratio of the Expenses (% of total expenses) in Subsidies and Transfers in 2007 to that in 2008?
Offer a very short reply. 0.98. What is the ratio of the Expenses (% of total expenses) of Other expenses in 2007 to that in 2008?
Give a very brief answer. 0.92. What is the difference between the highest and the second highest Expenses (% of total expenses) in Compensation of employees?
Offer a terse response. 0.09. What is the difference between the highest and the second highest Expenses (% of total expenses) of Goods and services?
Make the answer very short. 0.18. What is the difference between the highest and the second highest Expenses (% of total expenses) of Subsidies and Transfers?
Your answer should be compact. 0.5. What is the difference between the highest and the second highest Expenses (% of total expenses) of Other expenses?
Provide a succinct answer. 0.38. What is the difference between the highest and the lowest Expenses (% of total expenses) of Compensation of employees?
Your response must be concise. 1.69. What is the difference between the highest and the lowest Expenses (% of total expenses) of Goods and services?
Your response must be concise. 3.31. What is the difference between the highest and the lowest Expenses (% of total expenses) in Subsidies and Transfers?
Give a very brief answer. 7.06. What is the difference between the highest and the lowest Expenses (% of total expenses) of Other expenses?
Your answer should be compact. 2.02. 